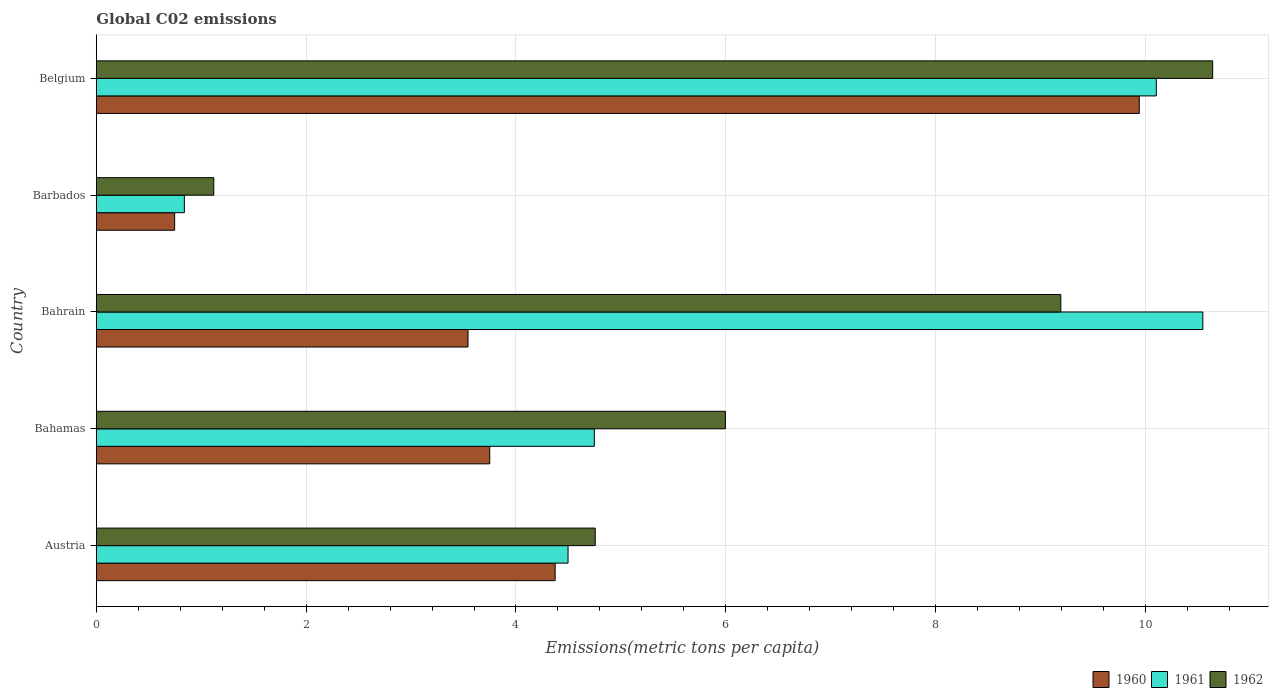Are the number of bars per tick equal to the number of legend labels?
Your answer should be compact. Yes. How many bars are there on the 1st tick from the bottom?
Give a very brief answer. 3. What is the label of the 3rd group of bars from the top?
Ensure brevity in your answer.  Bahrain. What is the amount of CO2 emitted in in 1962 in Bahrain?
Provide a short and direct response. 9.19. Across all countries, what is the maximum amount of CO2 emitted in in 1960?
Make the answer very short. 9.94. Across all countries, what is the minimum amount of CO2 emitted in in 1960?
Provide a short and direct response. 0.75. In which country was the amount of CO2 emitted in in 1961 maximum?
Provide a short and direct response. Bahrain. In which country was the amount of CO2 emitted in in 1961 minimum?
Give a very brief answer. Barbados. What is the total amount of CO2 emitted in in 1962 in the graph?
Keep it short and to the point. 31.71. What is the difference between the amount of CO2 emitted in in 1961 in Austria and that in Barbados?
Keep it short and to the point. 3.66. What is the difference between the amount of CO2 emitted in in 1960 in Bahamas and the amount of CO2 emitted in in 1961 in Barbados?
Your response must be concise. 2.91. What is the average amount of CO2 emitted in in 1961 per country?
Your answer should be compact. 6.15. What is the difference between the amount of CO2 emitted in in 1961 and amount of CO2 emitted in in 1960 in Bahrain?
Your answer should be very brief. 7. In how many countries, is the amount of CO2 emitted in in 1962 greater than 10.4 metric tons per capita?
Keep it short and to the point. 1. What is the ratio of the amount of CO2 emitted in in 1960 in Bahrain to that in Barbados?
Offer a terse response. 4.75. Is the difference between the amount of CO2 emitted in in 1961 in Bahrain and Barbados greater than the difference between the amount of CO2 emitted in in 1960 in Bahrain and Barbados?
Keep it short and to the point. Yes. What is the difference between the highest and the second highest amount of CO2 emitted in in 1960?
Offer a very short reply. 5.57. What is the difference between the highest and the lowest amount of CO2 emitted in in 1960?
Make the answer very short. 9.2. In how many countries, is the amount of CO2 emitted in in 1960 greater than the average amount of CO2 emitted in in 1960 taken over all countries?
Your answer should be very brief. 1. Is the sum of the amount of CO2 emitted in in 1961 in Austria and Bahamas greater than the maximum amount of CO2 emitted in in 1962 across all countries?
Your answer should be compact. No. How many bars are there?
Your answer should be compact. 15. Are all the bars in the graph horizontal?
Your answer should be very brief. Yes. What is the difference between two consecutive major ticks on the X-axis?
Make the answer very short. 2. Are the values on the major ticks of X-axis written in scientific E-notation?
Offer a terse response. No. Does the graph contain any zero values?
Give a very brief answer. No. Where does the legend appear in the graph?
Ensure brevity in your answer.  Bottom right. How many legend labels are there?
Your response must be concise. 3. How are the legend labels stacked?
Offer a terse response. Horizontal. What is the title of the graph?
Provide a short and direct response. Global C02 emissions. What is the label or title of the X-axis?
Provide a succinct answer. Emissions(metric tons per capita). What is the label or title of the Y-axis?
Your answer should be very brief. Country. What is the Emissions(metric tons per capita) in 1960 in Austria?
Give a very brief answer. 4.37. What is the Emissions(metric tons per capita) in 1961 in Austria?
Your answer should be very brief. 4.5. What is the Emissions(metric tons per capita) of 1962 in Austria?
Your answer should be compact. 4.76. What is the Emissions(metric tons per capita) in 1960 in Bahamas?
Offer a terse response. 3.75. What is the Emissions(metric tons per capita) in 1961 in Bahamas?
Keep it short and to the point. 4.75. What is the Emissions(metric tons per capita) of 1962 in Bahamas?
Make the answer very short. 6. What is the Emissions(metric tons per capita) of 1960 in Bahrain?
Your response must be concise. 3.54. What is the Emissions(metric tons per capita) in 1961 in Bahrain?
Make the answer very short. 10.55. What is the Emissions(metric tons per capita) of 1962 in Bahrain?
Give a very brief answer. 9.19. What is the Emissions(metric tons per capita) of 1960 in Barbados?
Provide a short and direct response. 0.75. What is the Emissions(metric tons per capita) in 1961 in Barbados?
Offer a very short reply. 0.84. What is the Emissions(metric tons per capita) of 1962 in Barbados?
Make the answer very short. 1.12. What is the Emissions(metric tons per capita) in 1960 in Belgium?
Make the answer very short. 9.94. What is the Emissions(metric tons per capita) of 1961 in Belgium?
Your answer should be compact. 10.1. What is the Emissions(metric tons per capita) of 1962 in Belgium?
Make the answer very short. 10.64. Across all countries, what is the maximum Emissions(metric tons per capita) in 1960?
Offer a very short reply. 9.94. Across all countries, what is the maximum Emissions(metric tons per capita) of 1961?
Give a very brief answer. 10.55. Across all countries, what is the maximum Emissions(metric tons per capita) of 1962?
Offer a terse response. 10.64. Across all countries, what is the minimum Emissions(metric tons per capita) of 1960?
Offer a very short reply. 0.75. Across all countries, what is the minimum Emissions(metric tons per capita) in 1961?
Provide a short and direct response. 0.84. Across all countries, what is the minimum Emissions(metric tons per capita) in 1962?
Give a very brief answer. 1.12. What is the total Emissions(metric tons per capita) of 1960 in the graph?
Your answer should be compact. 22.35. What is the total Emissions(metric tons per capita) in 1961 in the graph?
Offer a very short reply. 30.73. What is the total Emissions(metric tons per capita) of 1962 in the graph?
Your answer should be compact. 31.71. What is the difference between the Emissions(metric tons per capita) of 1960 in Austria and that in Bahamas?
Your answer should be compact. 0.62. What is the difference between the Emissions(metric tons per capita) in 1961 in Austria and that in Bahamas?
Provide a succinct answer. -0.25. What is the difference between the Emissions(metric tons per capita) of 1962 in Austria and that in Bahamas?
Offer a terse response. -1.24. What is the difference between the Emissions(metric tons per capita) in 1960 in Austria and that in Bahrain?
Keep it short and to the point. 0.83. What is the difference between the Emissions(metric tons per capita) in 1961 in Austria and that in Bahrain?
Provide a short and direct response. -6.05. What is the difference between the Emissions(metric tons per capita) in 1962 in Austria and that in Bahrain?
Offer a very short reply. -4.44. What is the difference between the Emissions(metric tons per capita) in 1960 in Austria and that in Barbados?
Provide a succinct answer. 3.63. What is the difference between the Emissions(metric tons per capita) in 1961 in Austria and that in Barbados?
Your answer should be very brief. 3.66. What is the difference between the Emissions(metric tons per capita) of 1962 in Austria and that in Barbados?
Make the answer very short. 3.64. What is the difference between the Emissions(metric tons per capita) of 1960 in Austria and that in Belgium?
Provide a short and direct response. -5.57. What is the difference between the Emissions(metric tons per capita) in 1961 in Austria and that in Belgium?
Offer a terse response. -5.61. What is the difference between the Emissions(metric tons per capita) in 1962 in Austria and that in Belgium?
Your response must be concise. -5.89. What is the difference between the Emissions(metric tons per capita) in 1960 in Bahamas and that in Bahrain?
Your answer should be very brief. 0.21. What is the difference between the Emissions(metric tons per capita) of 1961 in Bahamas and that in Bahrain?
Your answer should be very brief. -5.8. What is the difference between the Emissions(metric tons per capita) in 1962 in Bahamas and that in Bahrain?
Keep it short and to the point. -3.2. What is the difference between the Emissions(metric tons per capita) of 1960 in Bahamas and that in Barbados?
Provide a short and direct response. 3. What is the difference between the Emissions(metric tons per capita) in 1961 in Bahamas and that in Barbados?
Make the answer very short. 3.91. What is the difference between the Emissions(metric tons per capita) in 1962 in Bahamas and that in Barbados?
Provide a succinct answer. 4.88. What is the difference between the Emissions(metric tons per capita) in 1960 in Bahamas and that in Belgium?
Offer a very short reply. -6.19. What is the difference between the Emissions(metric tons per capita) of 1961 in Bahamas and that in Belgium?
Keep it short and to the point. -5.36. What is the difference between the Emissions(metric tons per capita) of 1962 in Bahamas and that in Belgium?
Offer a terse response. -4.64. What is the difference between the Emissions(metric tons per capita) of 1960 in Bahrain and that in Barbados?
Offer a terse response. 2.8. What is the difference between the Emissions(metric tons per capita) of 1961 in Bahrain and that in Barbados?
Offer a very short reply. 9.71. What is the difference between the Emissions(metric tons per capita) of 1962 in Bahrain and that in Barbados?
Your answer should be compact. 8.07. What is the difference between the Emissions(metric tons per capita) in 1960 in Bahrain and that in Belgium?
Make the answer very short. -6.4. What is the difference between the Emissions(metric tons per capita) of 1961 in Bahrain and that in Belgium?
Provide a short and direct response. 0.44. What is the difference between the Emissions(metric tons per capita) in 1962 in Bahrain and that in Belgium?
Keep it short and to the point. -1.45. What is the difference between the Emissions(metric tons per capita) in 1960 in Barbados and that in Belgium?
Offer a very short reply. -9.2. What is the difference between the Emissions(metric tons per capita) of 1961 in Barbados and that in Belgium?
Your answer should be compact. -9.27. What is the difference between the Emissions(metric tons per capita) of 1962 in Barbados and that in Belgium?
Offer a very short reply. -9.52. What is the difference between the Emissions(metric tons per capita) of 1960 in Austria and the Emissions(metric tons per capita) of 1961 in Bahamas?
Provide a succinct answer. -0.37. What is the difference between the Emissions(metric tons per capita) in 1960 in Austria and the Emissions(metric tons per capita) in 1962 in Bahamas?
Give a very brief answer. -1.62. What is the difference between the Emissions(metric tons per capita) in 1961 in Austria and the Emissions(metric tons per capita) in 1962 in Bahamas?
Offer a very short reply. -1.5. What is the difference between the Emissions(metric tons per capita) of 1960 in Austria and the Emissions(metric tons per capita) of 1961 in Bahrain?
Provide a short and direct response. -6.17. What is the difference between the Emissions(metric tons per capita) of 1960 in Austria and the Emissions(metric tons per capita) of 1962 in Bahrain?
Ensure brevity in your answer.  -4.82. What is the difference between the Emissions(metric tons per capita) in 1961 in Austria and the Emissions(metric tons per capita) in 1962 in Bahrain?
Ensure brevity in your answer.  -4.7. What is the difference between the Emissions(metric tons per capita) of 1960 in Austria and the Emissions(metric tons per capita) of 1961 in Barbados?
Keep it short and to the point. 3.53. What is the difference between the Emissions(metric tons per capita) in 1960 in Austria and the Emissions(metric tons per capita) in 1962 in Barbados?
Offer a terse response. 3.25. What is the difference between the Emissions(metric tons per capita) in 1961 in Austria and the Emissions(metric tons per capita) in 1962 in Barbados?
Provide a short and direct response. 3.38. What is the difference between the Emissions(metric tons per capita) in 1960 in Austria and the Emissions(metric tons per capita) in 1961 in Belgium?
Make the answer very short. -5.73. What is the difference between the Emissions(metric tons per capita) in 1960 in Austria and the Emissions(metric tons per capita) in 1962 in Belgium?
Offer a terse response. -6.27. What is the difference between the Emissions(metric tons per capita) of 1961 in Austria and the Emissions(metric tons per capita) of 1962 in Belgium?
Your answer should be very brief. -6.14. What is the difference between the Emissions(metric tons per capita) of 1960 in Bahamas and the Emissions(metric tons per capita) of 1961 in Bahrain?
Offer a terse response. -6.8. What is the difference between the Emissions(metric tons per capita) of 1960 in Bahamas and the Emissions(metric tons per capita) of 1962 in Bahrain?
Provide a succinct answer. -5.44. What is the difference between the Emissions(metric tons per capita) in 1961 in Bahamas and the Emissions(metric tons per capita) in 1962 in Bahrain?
Offer a terse response. -4.45. What is the difference between the Emissions(metric tons per capita) of 1960 in Bahamas and the Emissions(metric tons per capita) of 1961 in Barbados?
Offer a very short reply. 2.91. What is the difference between the Emissions(metric tons per capita) in 1960 in Bahamas and the Emissions(metric tons per capita) in 1962 in Barbados?
Your answer should be compact. 2.63. What is the difference between the Emissions(metric tons per capita) in 1961 in Bahamas and the Emissions(metric tons per capita) in 1962 in Barbados?
Your answer should be very brief. 3.63. What is the difference between the Emissions(metric tons per capita) in 1960 in Bahamas and the Emissions(metric tons per capita) in 1961 in Belgium?
Provide a short and direct response. -6.35. What is the difference between the Emissions(metric tons per capita) in 1960 in Bahamas and the Emissions(metric tons per capita) in 1962 in Belgium?
Offer a very short reply. -6.89. What is the difference between the Emissions(metric tons per capita) of 1961 in Bahamas and the Emissions(metric tons per capita) of 1962 in Belgium?
Make the answer very short. -5.89. What is the difference between the Emissions(metric tons per capita) in 1960 in Bahrain and the Emissions(metric tons per capita) in 1961 in Barbados?
Keep it short and to the point. 2.7. What is the difference between the Emissions(metric tons per capita) of 1960 in Bahrain and the Emissions(metric tons per capita) of 1962 in Barbados?
Provide a succinct answer. 2.42. What is the difference between the Emissions(metric tons per capita) in 1961 in Bahrain and the Emissions(metric tons per capita) in 1962 in Barbados?
Your response must be concise. 9.43. What is the difference between the Emissions(metric tons per capita) in 1960 in Bahrain and the Emissions(metric tons per capita) in 1961 in Belgium?
Your answer should be compact. -6.56. What is the difference between the Emissions(metric tons per capita) in 1960 in Bahrain and the Emissions(metric tons per capita) in 1962 in Belgium?
Provide a short and direct response. -7.1. What is the difference between the Emissions(metric tons per capita) of 1961 in Bahrain and the Emissions(metric tons per capita) of 1962 in Belgium?
Your answer should be compact. -0.09. What is the difference between the Emissions(metric tons per capita) in 1960 in Barbados and the Emissions(metric tons per capita) in 1961 in Belgium?
Give a very brief answer. -9.36. What is the difference between the Emissions(metric tons per capita) of 1960 in Barbados and the Emissions(metric tons per capita) of 1962 in Belgium?
Keep it short and to the point. -9.89. What is the difference between the Emissions(metric tons per capita) of 1961 in Barbados and the Emissions(metric tons per capita) of 1962 in Belgium?
Offer a terse response. -9.8. What is the average Emissions(metric tons per capita) of 1960 per country?
Your response must be concise. 4.47. What is the average Emissions(metric tons per capita) in 1961 per country?
Ensure brevity in your answer.  6.15. What is the average Emissions(metric tons per capita) in 1962 per country?
Give a very brief answer. 6.34. What is the difference between the Emissions(metric tons per capita) in 1960 and Emissions(metric tons per capita) in 1961 in Austria?
Your answer should be very brief. -0.12. What is the difference between the Emissions(metric tons per capita) in 1960 and Emissions(metric tons per capita) in 1962 in Austria?
Your answer should be very brief. -0.38. What is the difference between the Emissions(metric tons per capita) in 1961 and Emissions(metric tons per capita) in 1962 in Austria?
Ensure brevity in your answer.  -0.26. What is the difference between the Emissions(metric tons per capita) of 1960 and Emissions(metric tons per capita) of 1961 in Bahamas?
Your answer should be compact. -1. What is the difference between the Emissions(metric tons per capita) of 1960 and Emissions(metric tons per capita) of 1962 in Bahamas?
Provide a short and direct response. -2.25. What is the difference between the Emissions(metric tons per capita) of 1961 and Emissions(metric tons per capita) of 1962 in Bahamas?
Offer a terse response. -1.25. What is the difference between the Emissions(metric tons per capita) of 1960 and Emissions(metric tons per capita) of 1961 in Bahrain?
Make the answer very short. -7. What is the difference between the Emissions(metric tons per capita) of 1960 and Emissions(metric tons per capita) of 1962 in Bahrain?
Provide a succinct answer. -5.65. What is the difference between the Emissions(metric tons per capita) of 1961 and Emissions(metric tons per capita) of 1962 in Bahrain?
Keep it short and to the point. 1.35. What is the difference between the Emissions(metric tons per capita) of 1960 and Emissions(metric tons per capita) of 1961 in Barbados?
Give a very brief answer. -0.09. What is the difference between the Emissions(metric tons per capita) of 1960 and Emissions(metric tons per capita) of 1962 in Barbados?
Ensure brevity in your answer.  -0.37. What is the difference between the Emissions(metric tons per capita) of 1961 and Emissions(metric tons per capita) of 1962 in Barbados?
Your answer should be compact. -0.28. What is the difference between the Emissions(metric tons per capita) of 1960 and Emissions(metric tons per capita) of 1961 in Belgium?
Provide a succinct answer. -0.16. What is the difference between the Emissions(metric tons per capita) of 1960 and Emissions(metric tons per capita) of 1962 in Belgium?
Your answer should be compact. -0.7. What is the difference between the Emissions(metric tons per capita) of 1961 and Emissions(metric tons per capita) of 1962 in Belgium?
Your answer should be very brief. -0.54. What is the ratio of the Emissions(metric tons per capita) in 1960 in Austria to that in Bahamas?
Your answer should be very brief. 1.17. What is the ratio of the Emissions(metric tons per capita) in 1961 in Austria to that in Bahamas?
Offer a terse response. 0.95. What is the ratio of the Emissions(metric tons per capita) of 1962 in Austria to that in Bahamas?
Your answer should be compact. 0.79. What is the ratio of the Emissions(metric tons per capita) of 1960 in Austria to that in Bahrain?
Provide a short and direct response. 1.23. What is the ratio of the Emissions(metric tons per capita) in 1961 in Austria to that in Bahrain?
Your response must be concise. 0.43. What is the ratio of the Emissions(metric tons per capita) of 1962 in Austria to that in Bahrain?
Make the answer very short. 0.52. What is the ratio of the Emissions(metric tons per capita) of 1960 in Austria to that in Barbados?
Keep it short and to the point. 5.86. What is the ratio of the Emissions(metric tons per capita) in 1961 in Austria to that in Barbados?
Offer a terse response. 5.36. What is the ratio of the Emissions(metric tons per capita) in 1962 in Austria to that in Barbados?
Offer a very short reply. 4.25. What is the ratio of the Emissions(metric tons per capita) of 1960 in Austria to that in Belgium?
Your answer should be very brief. 0.44. What is the ratio of the Emissions(metric tons per capita) of 1961 in Austria to that in Belgium?
Your answer should be very brief. 0.45. What is the ratio of the Emissions(metric tons per capita) of 1962 in Austria to that in Belgium?
Your answer should be very brief. 0.45. What is the ratio of the Emissions(metric tons per capita) of 1960 in Bahamas to that in Bahrain?
Your response must be concise. 1.06. What is the ratio of the Emissions(metric tons per capita) in 1961 in Bahamas to that in Bahrain?
Your response must be concise. 0.45. What is the ratio of the Emissions(metric tons per capita) in 1962 in Bahamas to that in Bahrain?
Your answer should be compact. 0.65. What is the ratio of the Emissions(metric tons per capita) in 1960 in Bahamas to that in Barbados?
Provide a succinct answer. 5.02. What is the ratio of the Emissions(metric tons per capita) in 1961 in Bahamas to that in Barbados?
Keep it short and to the point. 5.66. What is the ratio of the Emissions(metric tons per capita) of 1962 in Bahamas to that in Barbados?
Your answer should be very brief. 5.36. What is the ratio of the Emissions(metric tons per capita) of 1960 in Bahamas to that in Belgium?
Keep it short and to the point. 0.38. What is the ratio of the Emissions(metric tons per capita) of 1961 in Bahamas to that in Belgium?
Provide a succinct answer. 0.47. What is the ratio of the Emissions(metric tons per capita) in 1962 in Bahamas to that in Belgium?
Ensure brevity in your answer.  0.56. What is the ratio of the Emissions(metric tons per capita) in 1960 in Bahrain to that in Barbados?
Offer a terse response. 4.75. What is the ratio of the Emissions(metric tons per capita) in 1961 in Bahrain to that in Barbados?
Make the answer very short. 12.57. What is the ratio of the Emissions(metric tons per capita) of 1962 in Bahrain to that in Barbados?
Offer a very short reply. 8.21. What is the ratio of the Emissions(metric tons per capita) of 1960 in Bahrain to that in Belgium?
Make the answer very short. 0.36. What is the ratio of the Emissions(metric tons per capita) in 1961 in Bahrain to that in Belgium?
Ensure brevity in your answer.  1.04. What is the ratio of the Emissions(metric tons per capita) in 1962 in Bahrain to that in Belgium?
Your answer should be compact. 0.86. What is the ratio of the Emissions(metric tons per capita) in 1960 in Barbados to that in Belgium?
Provide a succinct answer. 0.08. What is the ratio of the Emissions(metric tons per capita) of 1961 in Barbados to that in Belgium?
Provide a short and direct response. 0.08. What is the ratio of the Emissions(metric tons per capita) of 1962 in Barbados to that in Belgium?
Your answer should be compact. 0.11. What is the difference between the highest and the second highest Emissions(metric tons per capita) of 1960?
Provide a succinct answer. 5.57. What is the difference between the highest and the second highest Emissions(metric tons per capita) of 1961?
Offer a terse response. 0.44. What is the difference between the highest and the second highest Emissions(metric tons per capita) in 1962?
Keep it short and to the point. 1.45. What is the difference between the highest and the lowest Emissions(metric tons per capita) of 1960?
Offer a very short reply. 9.2. What is the difference between the highest and the lowest Emissions(metric tons per capita) of 1961?
Offer a very short reply. 9.71. What is the difference between the highest and the lowest Emissions(metric tons per capita) of 1962?
Ensure brevity in your answer.  9.52. 